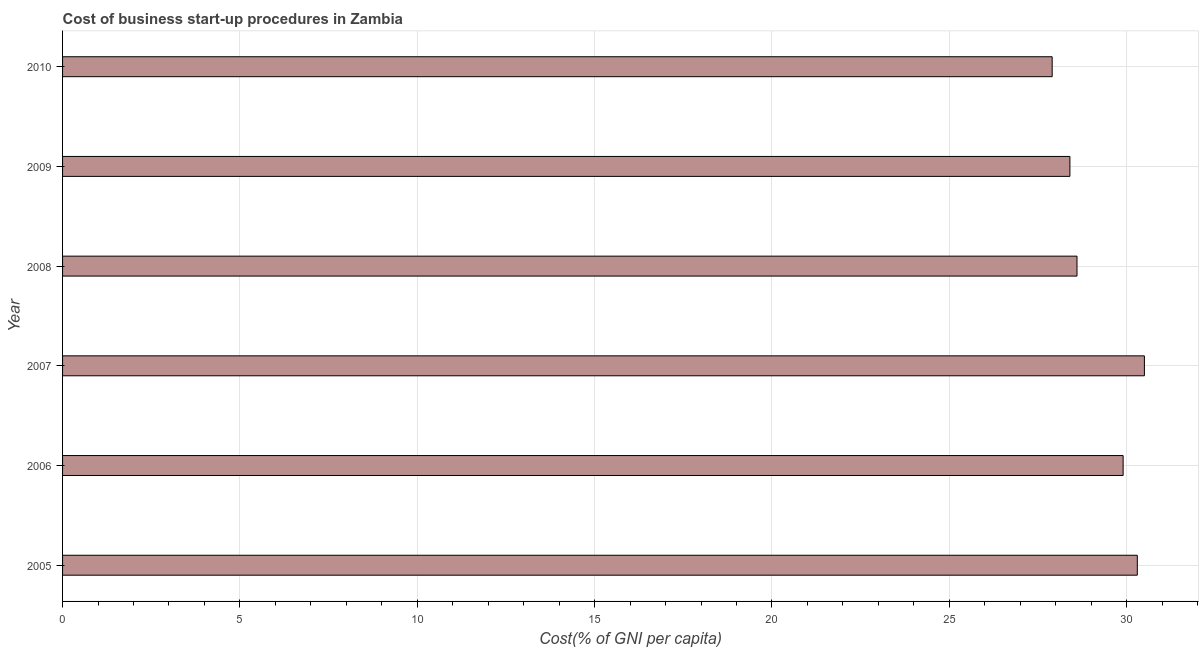What is the title of the graph?
Your response must be concise. Cost of business start-up procedures in Zambia. What is the label or title of the X-axis?
Provide a succinct answer. Cost(% of GNI per capita). What is the label or title of the Y-axis?
Offer a terse response. Year. What is the cost of business startup procedures in 2007?
Your answer should be compact. 30.5. Across all years, what is the maximum cost of business startup procedures?
Provide a succinct answer. 30.5. Across all years, what is the minimum cost of business startup procedures?
Give a very brief answer. 27.9. In which year was the cost of business startup procedures maximum?
Ensure brevity in your answer.  2007. What is the sum of the cost of business startup procedures?
Provide a succinct answer. 175.6. What is the difference between the cost of business startup procedures in 2006 and 2009?
Make the answer very short. 1.5. What is the average cost of business startup procedures per year?
Your answer should be very brief. 29.27. What is the median cost of business startup procedures?
Offer a terse response. 29.25. In how many years, is the cost of business startup procedures greater than 27 %?
Your answer should be very brief. 6. What is the ratio of the cost of business startup procedures in 2007 to that in 2008?
Keep it short and to the point. 1.07. Is the difference between the cost of business startup procedures in 2007 and 2009 greater than the difference between any two years?
Provide a succinct answer. No. Is the sum of the cost of business startup procedures in 2005 and 2010 greater than the maximum cost of business startup procedures across all years?
Keep it short and to the point. Yes. How many bars are there?
Provide a succinct answer. 6. Are all the bars in the graph horizontal?
Keep it short and to the point. Yes. How many years are there in the graph?
Offer a terse response. 6. What is the Cost(% of GNI per capita) in 2005?
Make the answer very short. 30.3. What is the Cost(% of GNI per capita) in 2006?
Give a very brief answer. 29.9. What is the Cost(% of GNI per capita) of 2007?
Provide a short and direct response. 30.5. What is the Cost(% of GNI per capita) of 2008?
Offer a terse response. 28.6. What is the Cost(% of GNI per capita) in 2009?
Provide a succinct answer. 28.4. What is the Cost(% of GNI per capita) in 2010?
Offer a terse response. 27.9. What is the difference between the Cost(% of GNI per capita) in 2005 and 2007?
Ensure brevity in your answer.  -0.2. What is the difference between the Cost(% of GNI per capita) in 2005 and 2009?
Provide a short and direct response. 1.9. What is the difference between the Cost(% of GNI per capita) in 2006 and 2008?
Offer a terse response. 1.3. What is the difference between the Cost(% of GNI per capita) in 2006 and 2010?
Ensure brevity in your answer.  2. What is the difference between the Cost(% of GNI per capita) in 2008 and 2010?
Offer a terse response. 0.7. What is the difference between the Cost(% of GNI per capita) in 2009 and 2010?
Give a very brief answer. 0.5. What is the ratio of the Cost(% of GNI per capita) in 2005 to that in 2008?
Provide a short and direct response. 1.06. What is the ratio of the Cost(% of GNI per capita) in 2005 to that in 2009?
Make the answer very short. 1.07. What is the ratio of the Cost(% of GNI per capita) in 2005 to that in 2010?
Provide a succinct answer. 1.09. What is the ratio of the Cost(% of GNI per capita) in 2006 to that in 2007?
Offer a very short reply. 0.98. What is the ratio of the Cost(% of GNI per capita) in 2006 to that in 2008?
Provide a succinct answer. 1.04. What is the ratio of the Cost(% of GNI per capita) in 2006 to that in 2009?
Provide a short and direct response. 1.05. What is the ratio of the Cost(% of GNI per capita) in 2006 to that in 2010?
Provide a succinct answer. 1.07. What is the ratio of the Cost(% of GNI per capita) in 2007 to that in 2008?
Your answer should be compact. 1.07. What is the ratio of the Cost(% of GNI per capita) in 2007 to that in 2009?
Your response must be concise. 1.07. What is the ratio of the Cost(% of GNI per capita) in 2007 to that in 2010?
Offer a very short reply. 1.09. What is the ratio of the Cost(% of GNI per capita) in 2008 to that in 2010?
Your answer should be compact. 1.02. 